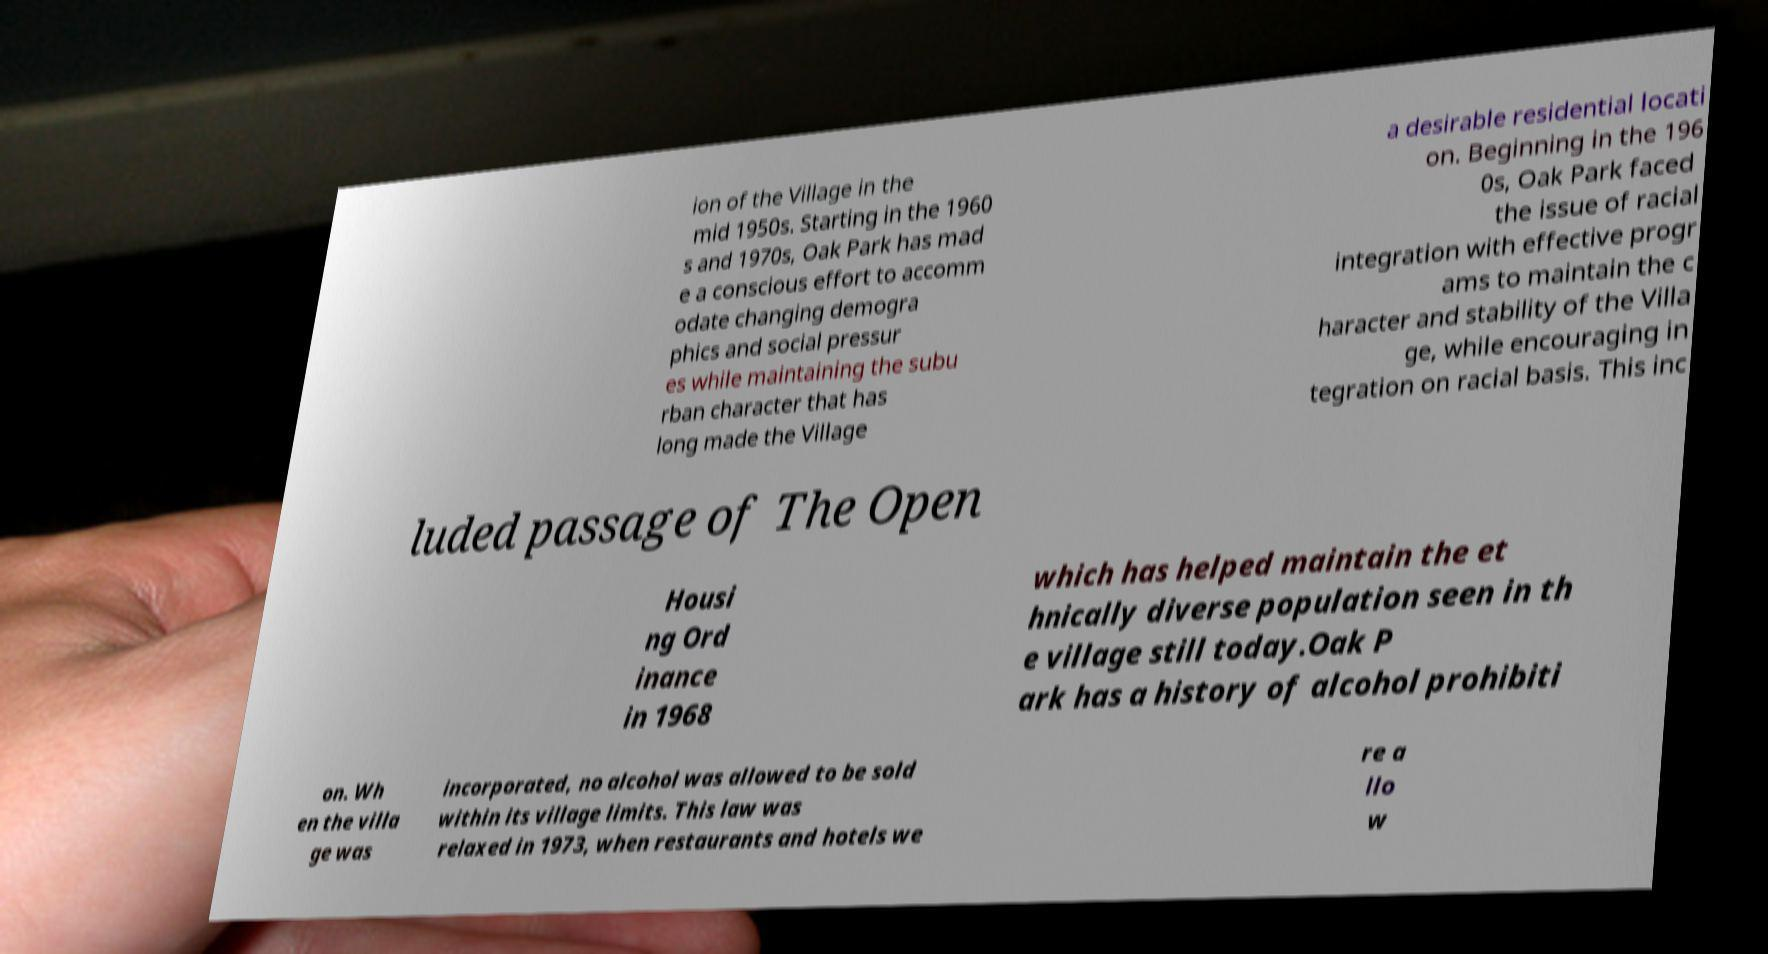For documentation purposes, I need the text within this image transcribed. Could you provide that? ion of the Village in the mid 1950s. Starting in the 1960 s and 1970s, Oak Park has mad e a conscious effort to accomm odate changing demogra phics and social pressur es while maintaining the subu rban character that has long made the Village a desirable residential locati on. Beginning in the 196 0s, Oak Park faced the issue of racial integration with effective progr ams to maintain the c haracter and stability of the Villa ge, while encouraging in tegration on racial basis. This inc luded passage of The Open Housi ng Ord inance in 1968 which has helped maintain the et hnically diverse population seen in th e village still today.Oak P ark has a history of alcohol prohibiti on. Wh en the villa ge was incorporated, no alcohol was allowed to be sold within its village limits. This law was relaxed in 1973, when restaurants and hotels we re a llo w 